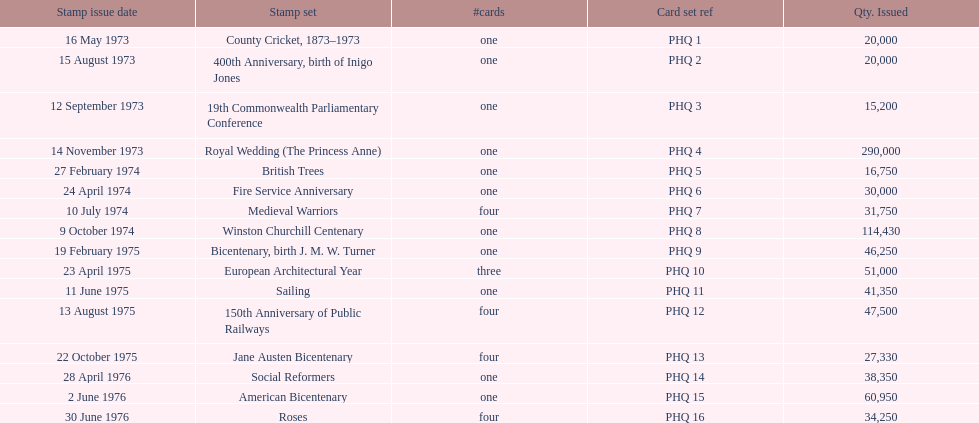Which stamp sets include multiple cards? Medieval Warriors, European Architectural Year, 150th Anniversary of Public Railways, Jane Austen Bicentenary, Roses. From these sets, which has an exclusive quantity of cards? European Architectural Year. 